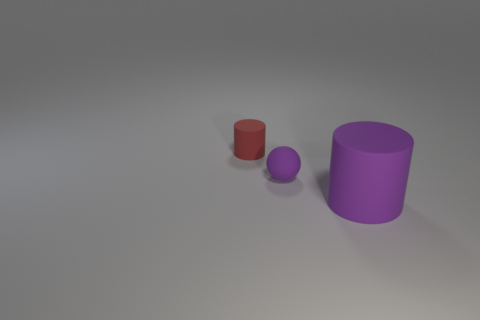Add 1 tiny red rubber things. How many objects exist? 4 Subtract all cylinders. How many objects are left? 1 Add 1 small purple things. How many small purple things are left? 2 Add 1 rubber spheres. How many rubber spheres exist? 2 Subtract 0 cyan cubes. How many objects are left? 3 Subtract all purple matte cylinders. Subtract all big matte cylinders. How many objects are left? 1 